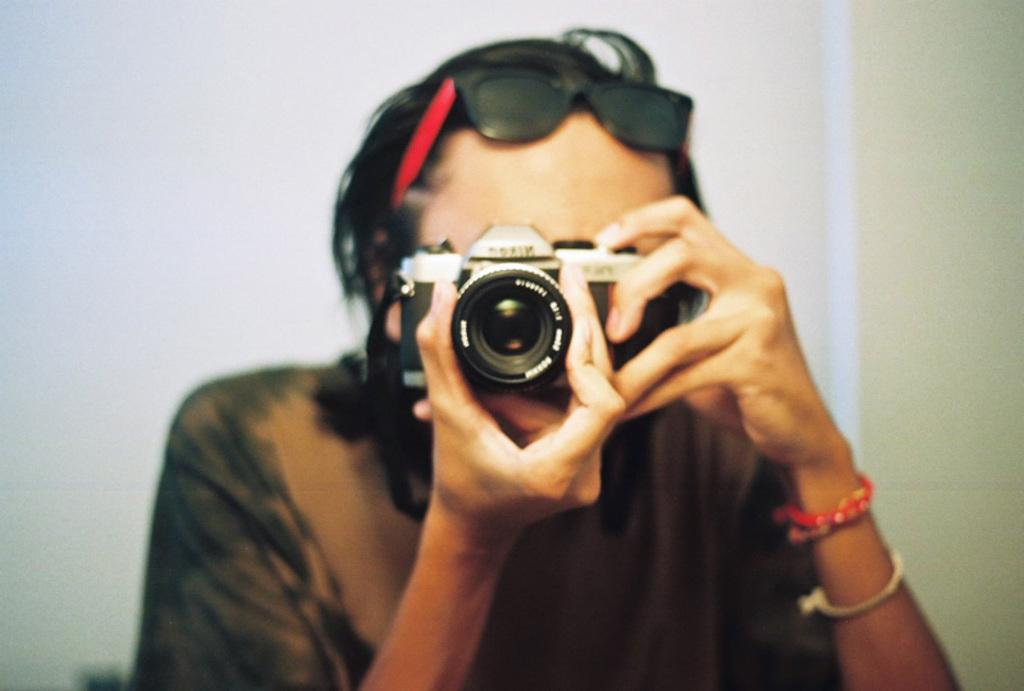Who is taking the picture in the image? There is a person holding the camera in the image. What can be seen behind the person taking the picture? There is a wall in the background of the image. What books are the person holding the camera reading in the image? There are no books visible in the image; it only shows a person holding a camera with a wall in the background. 